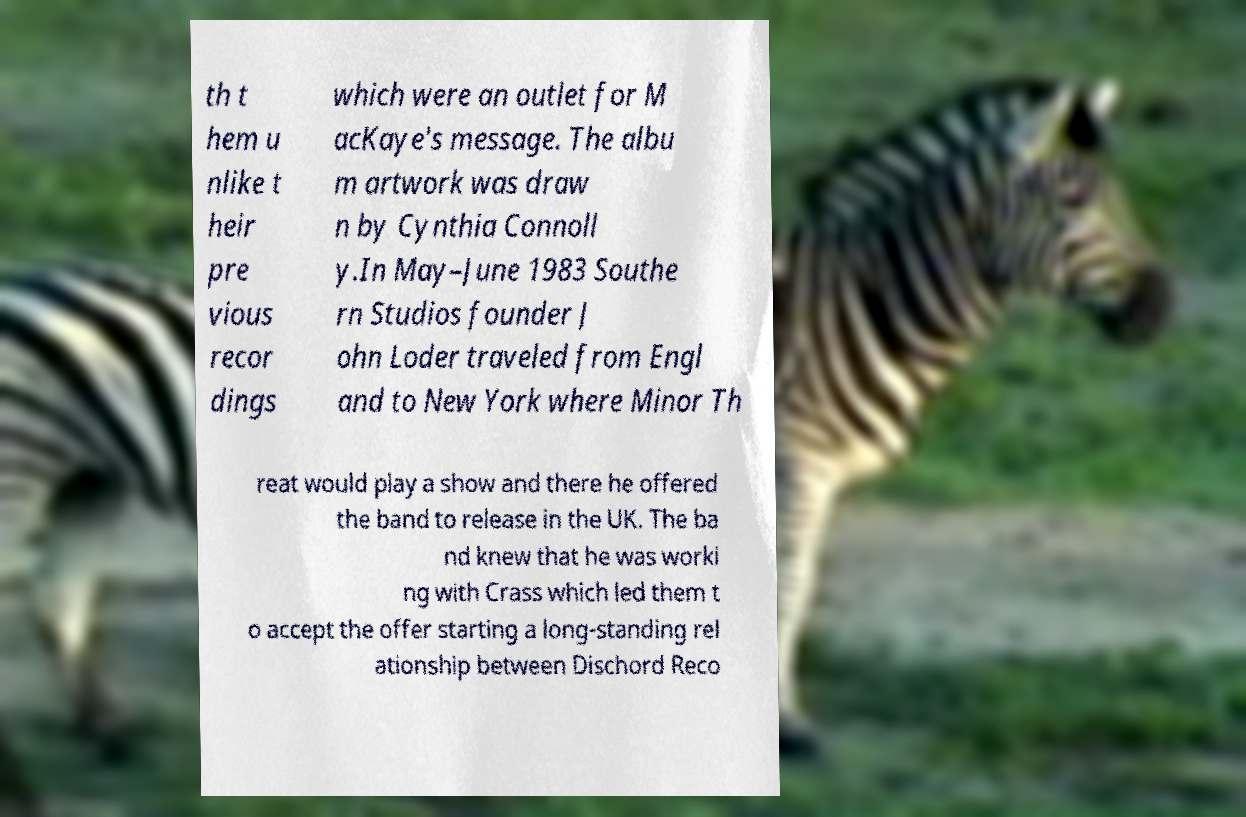Please identify and transcribe the text found in this image. th t hem u nlike t heir pre vious recor dings which were an outlet for M acKaye's message. The albu m artwork was draw n by Cynthia Connoll y.In May–June 1983 Southe rn Studios founder J ohn Loder traveled from Engl and to New York where Minor Th reat would play a show and there he offered the band to release in the UK. The ba nd knew that he was worki ng with Crass which led them t o accept the offer starting a long-standing rel ationship between Dischord Reco 